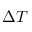Convert formula to latex. <formula><loc_0><loc_0><loc_500><loc_500>\Delta T</formula> 